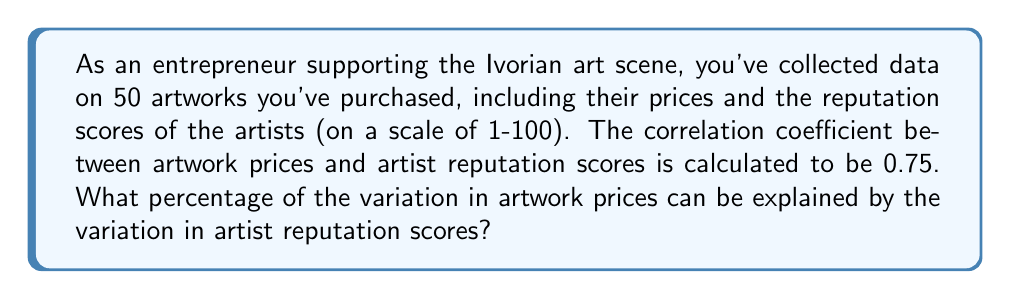Show me your answer to this math problem. To solve this problem, we need to understand the concept of the coefficient of determination, also known as R-squared (R²). The coefficient of determination is the square of the correlation coefficient (r) and represents the proportion of variance in the dependent variable (artwork prices) that is predictable from the independent variable (artist reputation scores).

Step 1: Identify the correlation coefficient (r)
r = 0.75

Step 2: Calculate R-squared (R²)
R² = r²
R² = (0.75)²
R² = 0.5625

Step 3: Convert R² to a percentage
Percentage = R² × 100%
Percentage = 0.5625 × 100% = 56.25%

Therefore, 56.25% of the variation in artwork prices can be explained by the variation in artist reputation scores.

This means that there is a moderate to strong relationship between artist reputation and artwork prices in your collection. However, it also indicates that other factors (accounting for the remaining 43.75% of the variation) also influence artwork prices.
Answer: 56.25% 